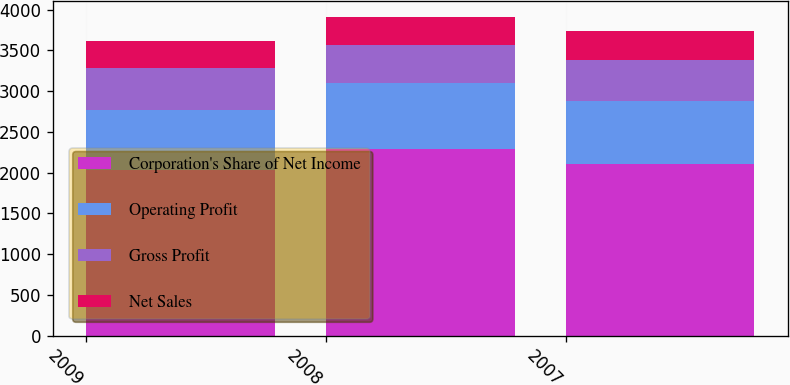Convert chart to OTSL. <chart><loc_0><loc_0><loc_500><loc_500><stacked_bar_chart><ecel><fcel>2009<fcel>2008<fcel>2007<nl><fcel>Corporation's Share of Net Income<fcel>2033<fcel>2286<fcel>2108<nl><fcel>Operating Profit<fcel>740<fcel>812<fcel>768<nl><fcel>Gross Profit<fcel>505<fcel>464<fcel>506<nl><fcel>Net Sales<fcel>341<fcel>349<fcel>357<nl></chart> 